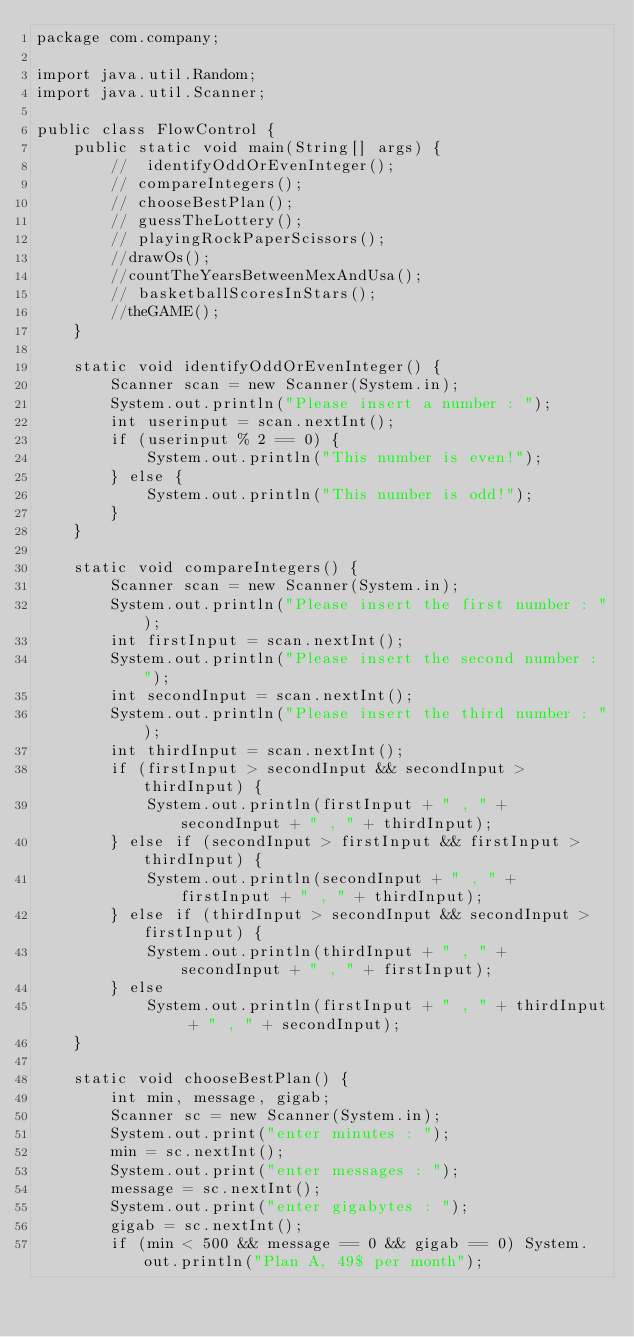Convert code to text. <code><loc_0><loc_0><loc_500><loc_500><_Java_>package com.company;

import java.util.Random;
import java.util.Scanner;

public class FlowControl {
    public static void main(String[] args) {
        //  identifyOddOrEvenInteger();
        // compareIntegers();
        // chooseBestPlan();
        // guessTheLottery();
        // playingRockPaperScissors();
        //drawOs();
        //countTheYearsBetweenMexAndUsa();
        // basketballScoresInStars();
        //theGAME();
    }

    static void identifyOddOrEvenInteger() {
        Scanner scan = new Scanner(System.in);
        System.out.println("Please insert a number : ");
        int userinput = scan.nextInt();
        if (userinput % 2 == 0) {
            System.out.println("This number is even!");
        } else {
            System.out.println("This number is odd!");
        }
    }

    static void compareIntegers() {
        Scanner scan = new Scanner(System.in);
        System.out.println("Please insert the first number : ");
        int firstInput = scan.nextInt();
        System.out.println("Please insert the second number : ");
        int secondInput = scan.nextInt();
        System.out.println("Please insert the third number : ");
        int thirdInput = scan.nextInt();
        if (firstInput > secondInput && secondInput > thirdInput) {
            System.out.println(firstInput + " , " + secondInput + " , " + thirdInput);
        } else if (secondInput > firstInput && firstInput > thirdInput) {
            System.out.println(secondInput + " , " + firstInput + " , " + thirdInput);
        } else if (thirdInput > secondInput && secondInput > firstInput) {
            System.out.println(thirdInput + " , " + secondInput + " , " + firstInput);
        } else
            System.out.println(firstInput + " , " + thirdInput + " , " + secondInput);
    }

    static void chooseBestPlan() {
        int min, message, gigab;
        Scanner sc = new Scanner(System.in);
        System.out.print("enter minutes : ");
        min = sc.nextInt();
        System.out.print("enter messages : ");
        message = sc.nextInt();
        System.out.print("enter gigabytes : ");
        gigab = sc.nextInt();
        if (min < 500 && message == 0 && gigab == 0) System.out.println("Plan A, 49$ per month");</code> 